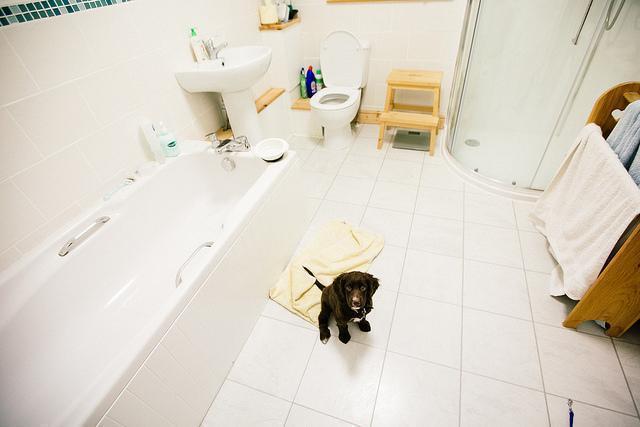Why might the dog be near the tub?
Indicate the correct response and explain using: 'Answer: answer
Rationale: rationale.'
Options: To bathe, to guard, to play, to eat. Answer: to bathe.
Rationale: Some dogs love to take a bath. 